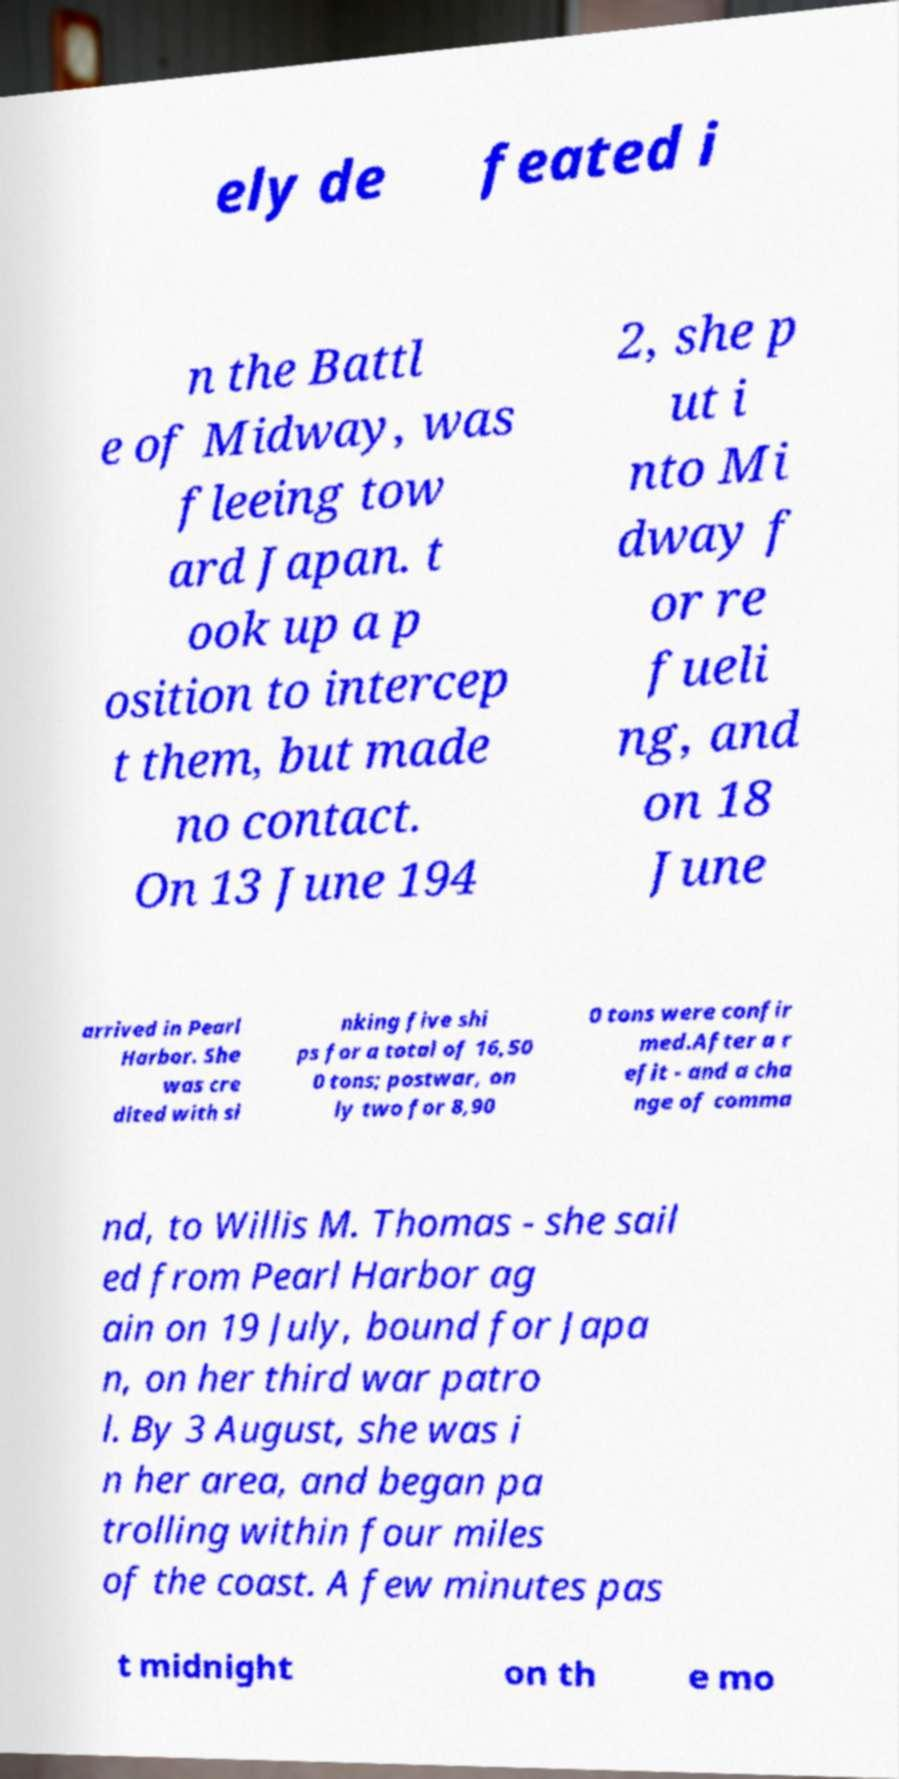For documentation purposes, I need the text within this image transcribed. Could you provide that? ely de feated i n the Battl e of Midway, was fleeing tow ard Japan. t ook up a p osition to intercep t them, but made no contact. On 13 June 194 2, she p ut i nto Mi dway f or re fueli ng, and on 18 June arrived in Pearl Harbor. She was cre dited with si nking five shi ps for a total of 16,50 0 tons; postwar, on ly two for 8,90 0 tons were confir med.After a r efit - and a cha nge of comma nd, to Willis M. Thomas - she sail ed from Pearl Harbor ag ain on 19 July, bound for Japa n, on her third war patro l. By 3 August, she was i n her area, and began pa trolling within four miles of the coast. A few minutes pas t midnight on th e mo 